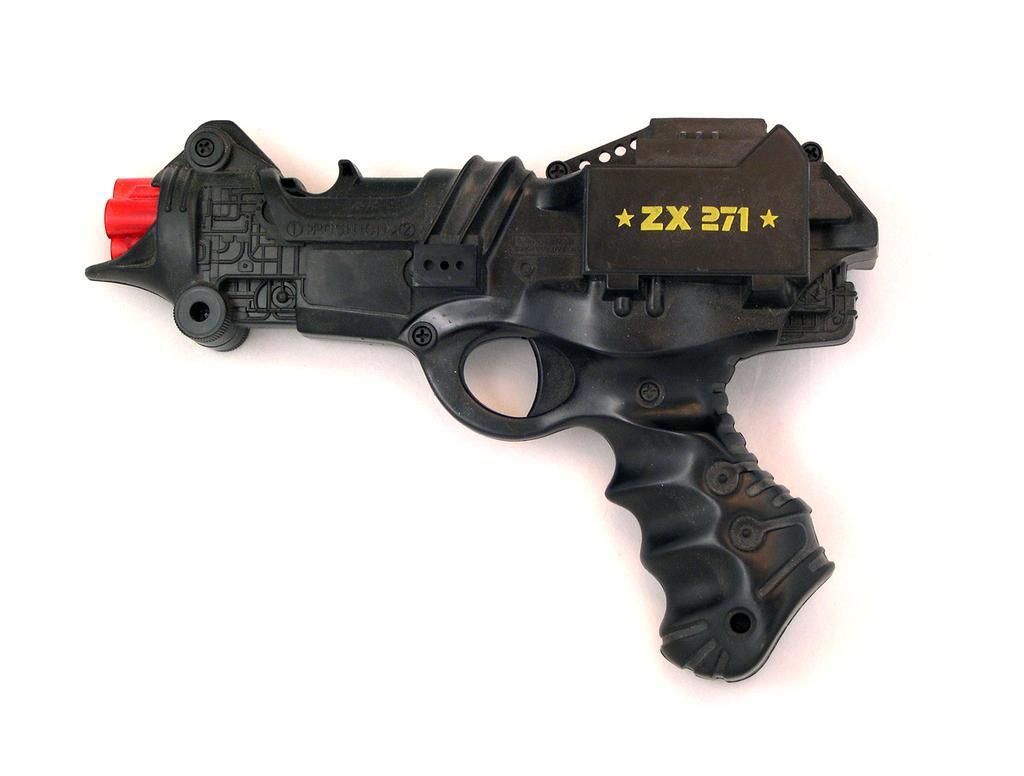Describe this image in one or two sentences. In the picture we can see a toy gun which is black in color and written on it as ZX 271. 